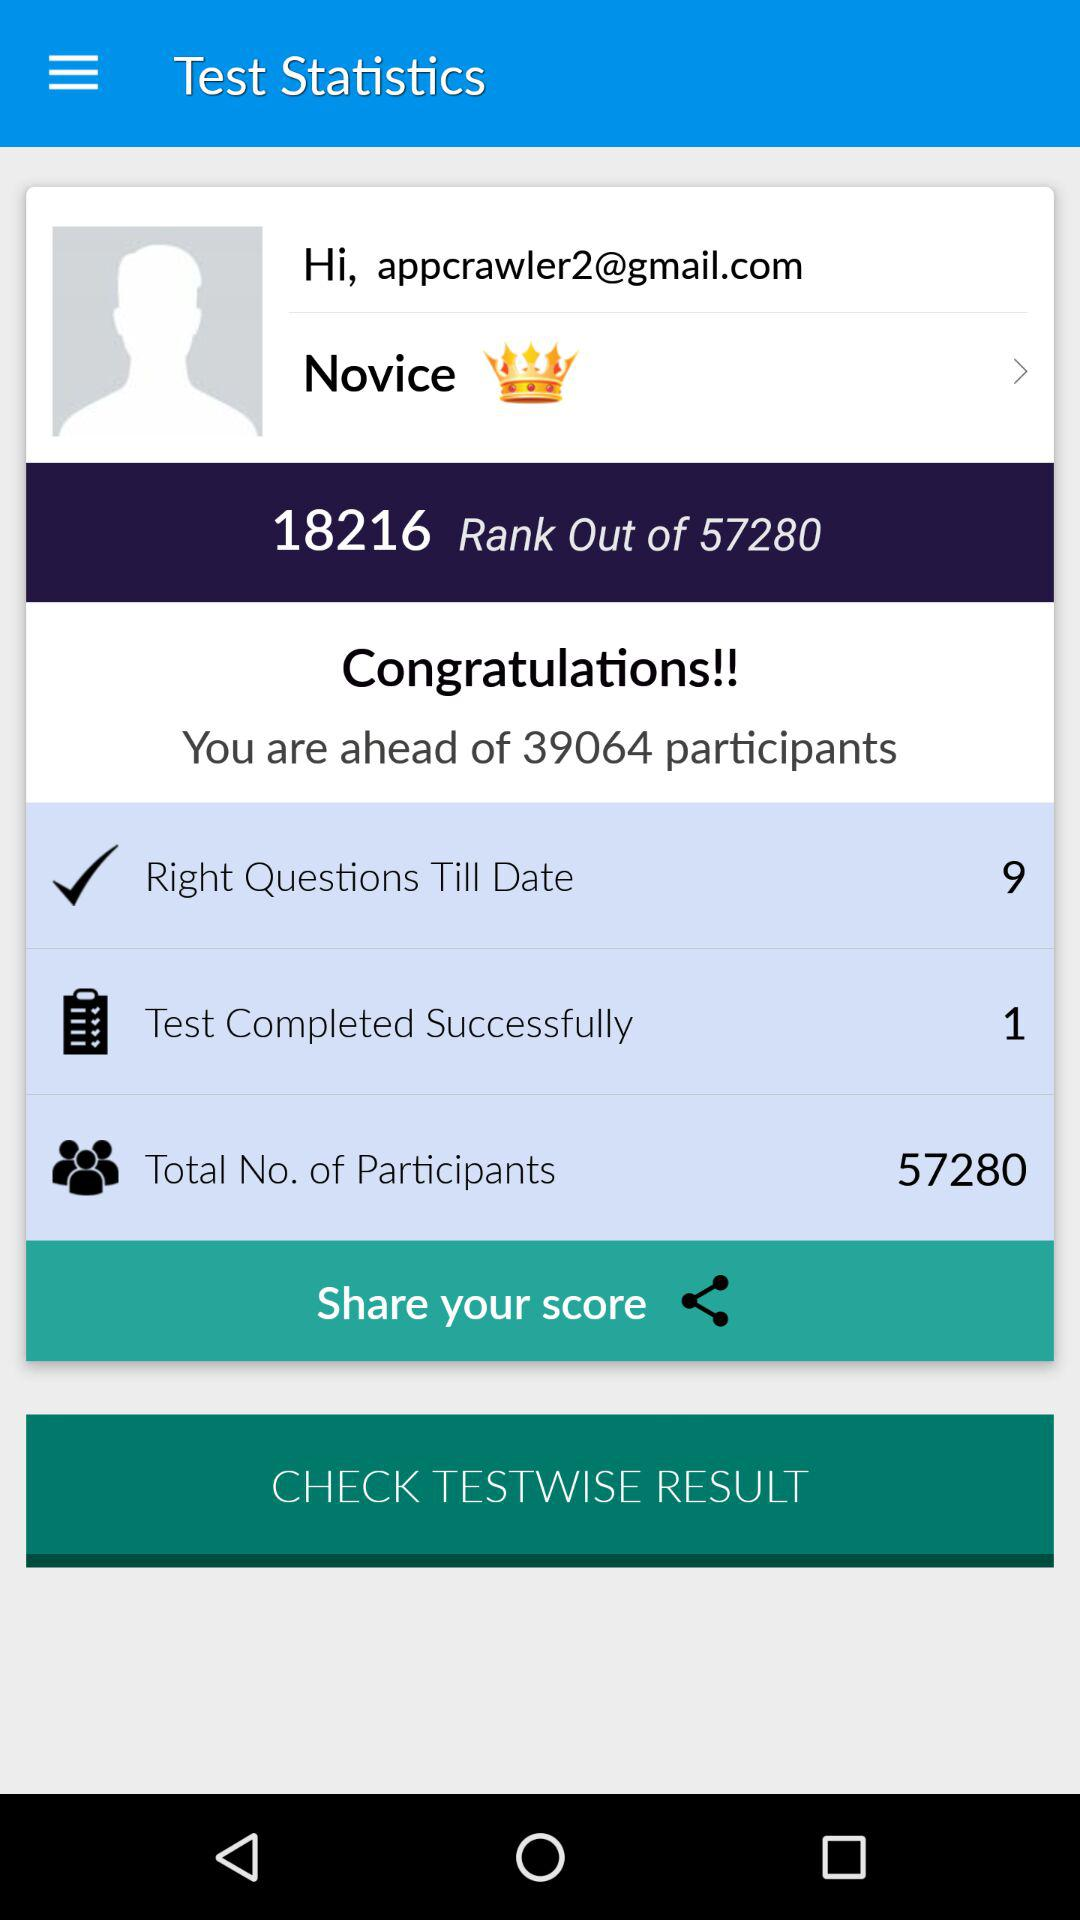What is the Gmail address? The Gmail address is appcrawler2@gmail.com. 